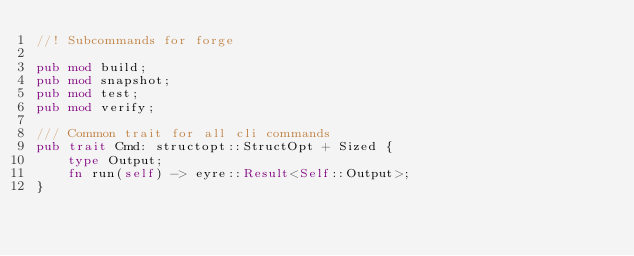Convert code to text. <code><loc_0><loc_0><loc_500><loc_500><_Rust_>//! Subcommands for forge

pub mod build;
pub mod snapshot;
pub mod test;
pub mod verify;

/// Common trait for all cli commands
pub trait Cmd: structopt::StructOpt + Sized {
    type Output;
    fn run(self) -> eyre::Result<Self::Output>;
}
</code> 